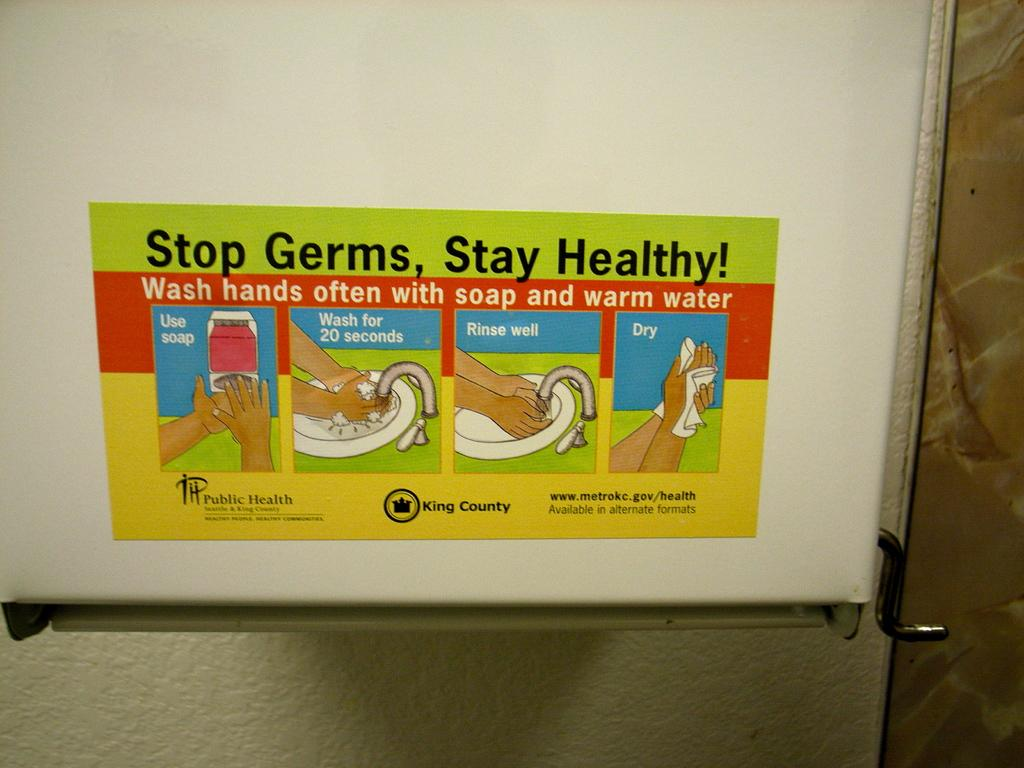<image>
Offer a succinct explanation of the picture presented. a refrigerator sticker that says 'stop germs, stay healthy!' 